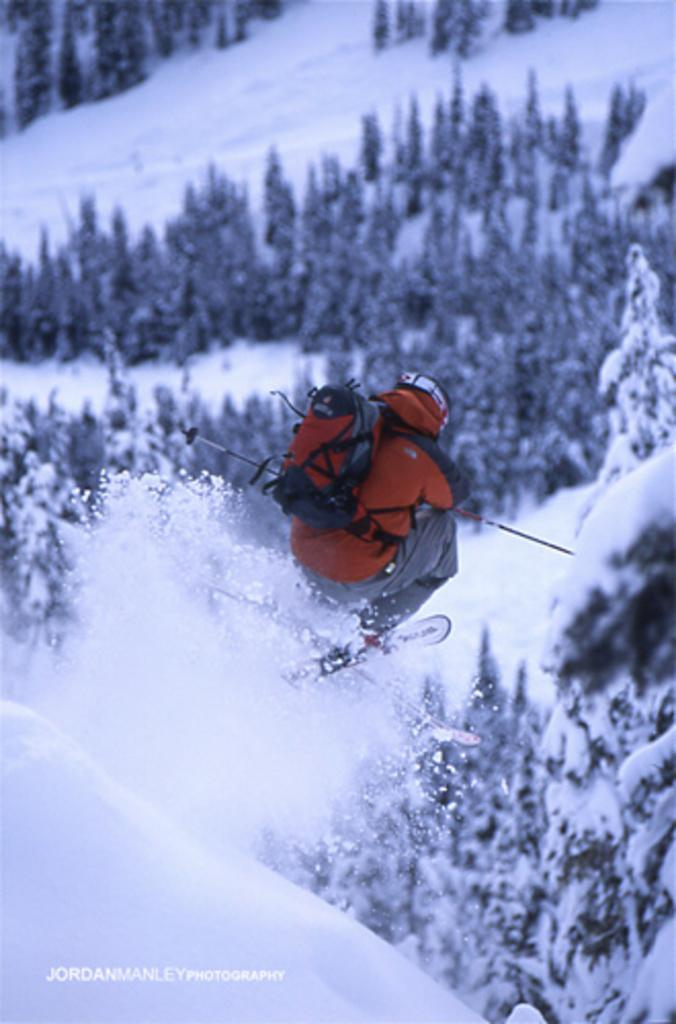What is the main subject of the image? There is a person in the image. What is the person wearing? The person is wearing a bag. What is the person holding? The person is holding sticks. What activity is the person engaged in? The person is skiing. What type of environment is visible in the image? There are trees and snow visible in the image. Is there any text present in the image? Yes, there is text at the bottom of the image. What type of magic is the person performing with the pencil in the image? There is no pencil present in the image, and therefore no magic can be observed. 